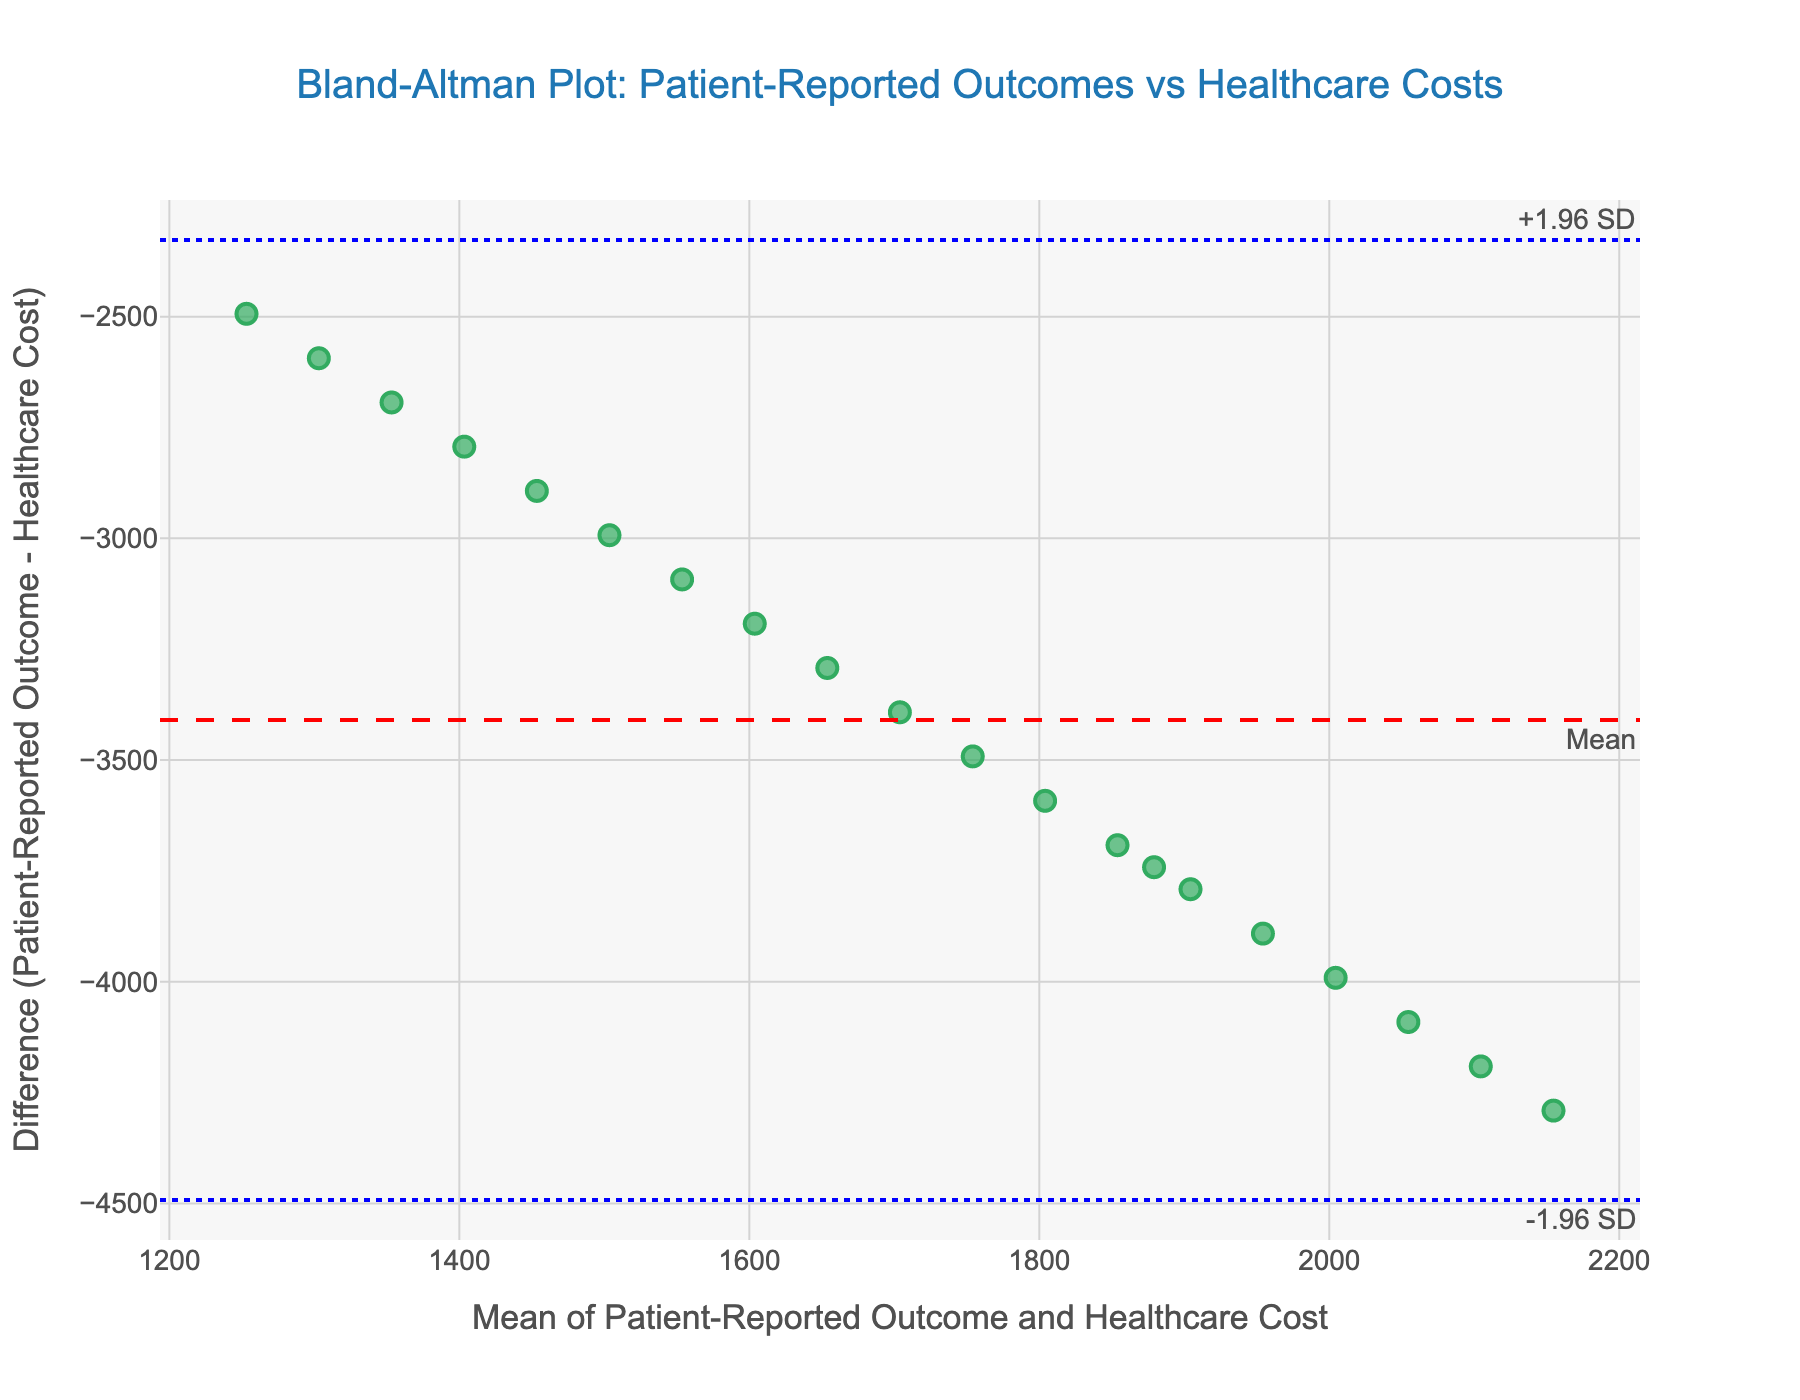What is the title of the figure? The title is provided at the top of the figure, indicating the main subject.
Answer: Bland-Altman Plot: Patient-Reported Outcomes vs Healthcare Costs What do the axes in the figure represent? The x-axis represents the mean of the Patient-Reported Outcome and Healthcare Cost, and the y-axis represents the difference between the Patient-Reported Outcome and the Healthcare Cost.
Answer: Mean vs Difference How many data points are plotted in the figure? Count the number of scatter points present in the plot; each point is a unique data point.
Answer: 20 What color represents the data points in the plot? The data points are represented using a specific color in the plot.
Answer: Green with a dark green outline What do the dashed red line and the dotted blue lines represent? The dashed red line represents the mean difference, and the dotted blue lines represent the limits of agreement (-1.96 SD and +1.96 SD).
Answer: Mean difference and limits of agreement How would you describe the overall agreement between patient-reported outcomes and healthcare costs based on the plot? Look at how the data points are distributed around the mean difference and within the limits of agreement.
Answer: Moderate agreement What is the range of values on the x-axis? Identify the minimum and maximum values marked on the x-axis scale.
Answer: Approx. 1350 to 4200 Is there a general trend observable from the data points’ distribution around the mean difference line? Analyze if data points are equally distributed around the mean difference line or show any deviation pattern.
Answer: Data points are fairly scattered around the mean difference line How many data points fall outside the limits of agreement? Count the number of data points that lie above the upper limit or below the lower limit of agreement lines.
Answer: 0 What does it imply if most data points are within the limits of agreement in the plot? This implies that the differences between the patient-reported outcomes and healthcare costs are consistent with the calculation limits based on the mean difference and standard deviations.
Answer: The differences are consistent 